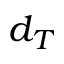Convert formula to latex. <formula><loc_0><loc_0><loc_500><loc_500>d _ { T }</formula> 